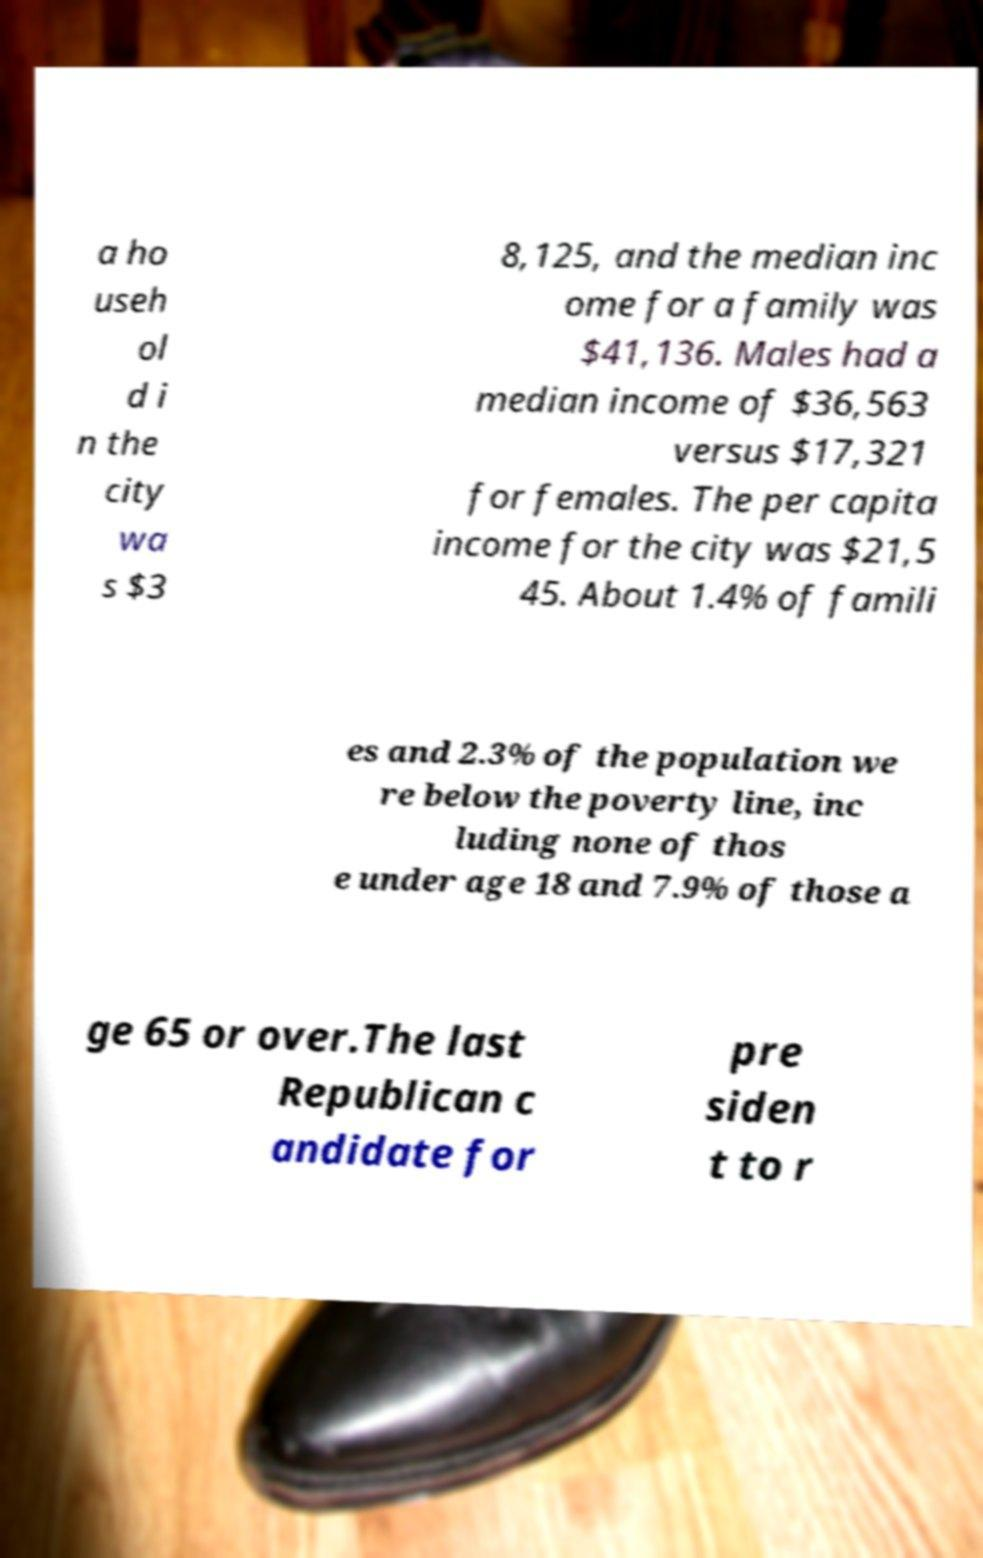Can you read and provide the text displayed in the image?This photo seems to have some interesting text. Can you extract and type it out for me? a ho useh ol d i n the city wa s $3 8,125, and the median inc ome for a family was $41,136. Males had a median income of $36,563 versus $17,321 for females. The per capita income for the city was $21,5 45. About 1.4% of famili es and 2.3% of the population we re below the poverty line, inc luding none of thos e under age 18 and 7.9% of those a ge 65 or over.The last Republican c andidate for pre siden t to r 